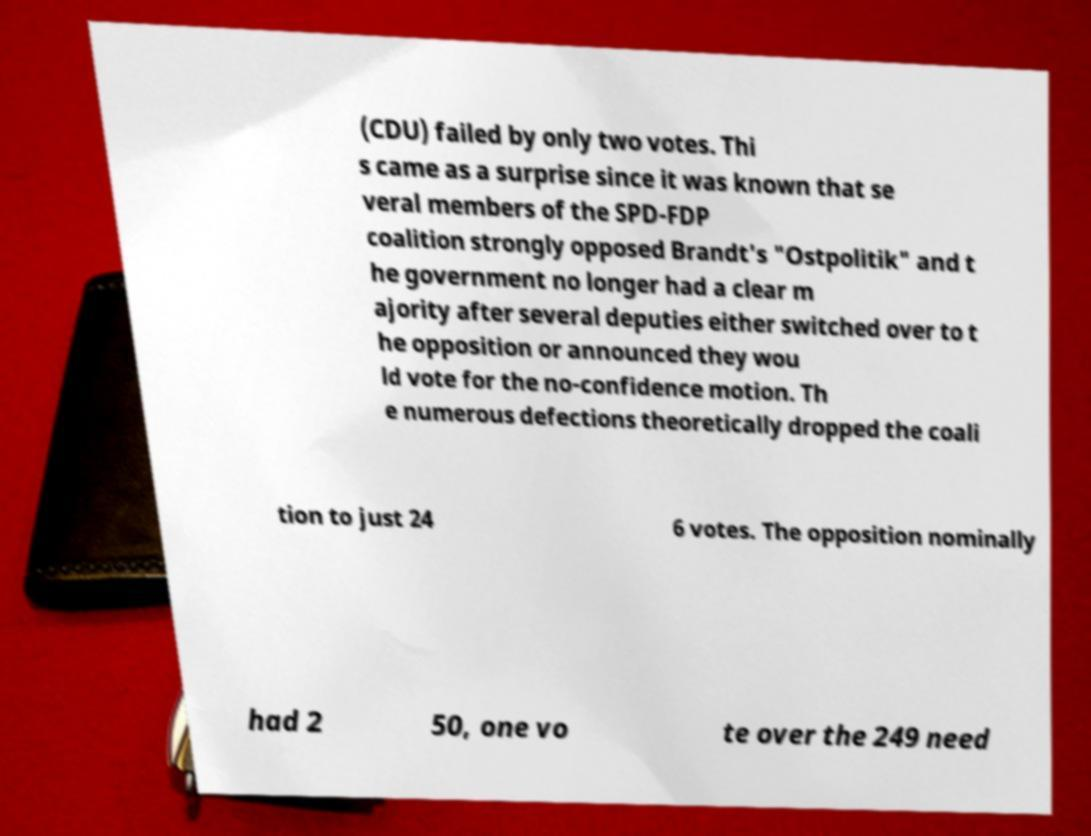I need the written content from this picture converted into text. Can you do that? (CDU) failed by only two votes. Thi s came as a surprise since it was known that se veral members of the SPD-FDP coalition strongly opposed Brandt's "Ostpolitik" and t he government no longer had a clear m ajority after several deputies either switched over to t he opposition or announced they wou ld vote for the no-confidence motion. Th e numerous defections theoretically dropped the coali tion to just 24 6 votes. The opposition nominally had 2 50, one vo te over the 249 need 